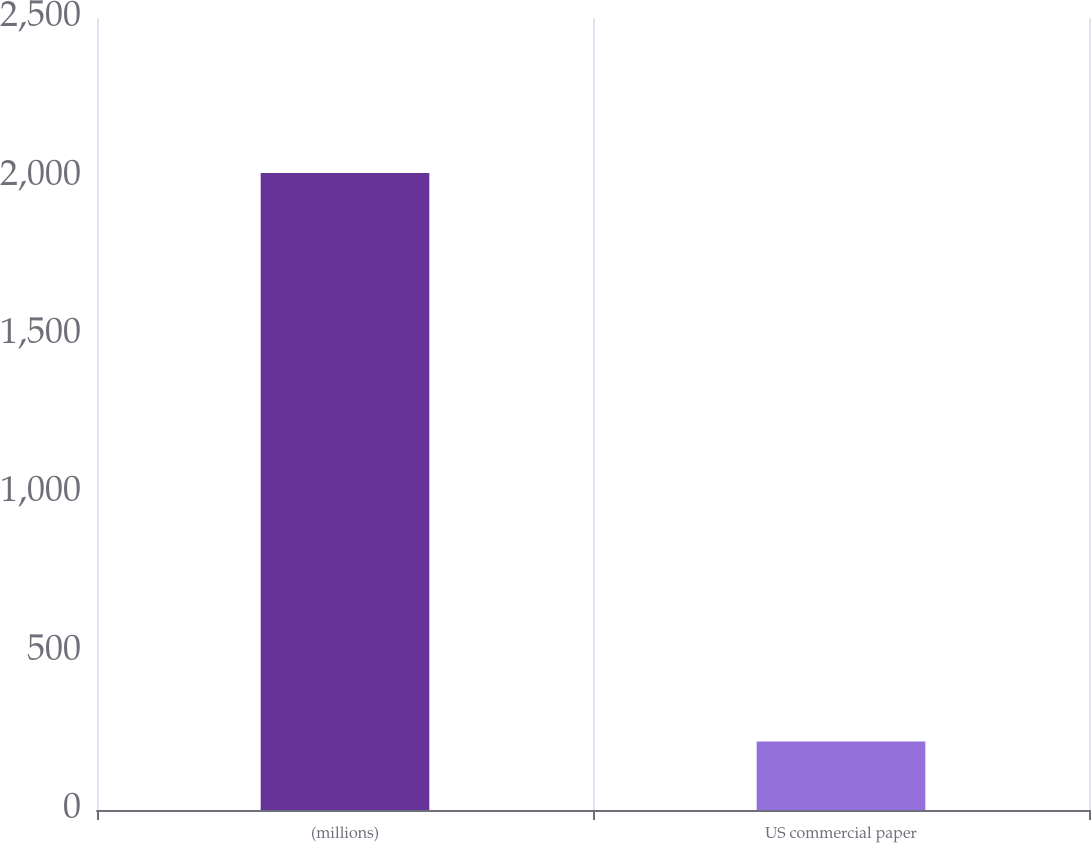<chart> <loc_0><loc_0><loc_500><loc_500><bar_chart><fcel>(millions)<fcel>US commercial paper<nl><fcel>2011<fcel>216<nl></chart> 